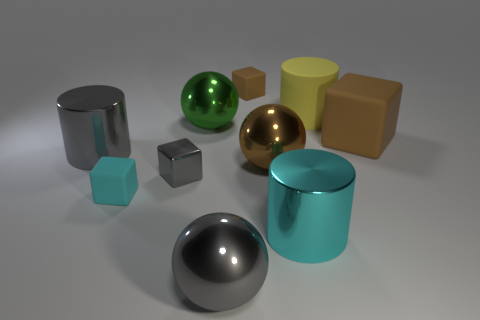Subtract all blocks. How many objects are left? 6 Add 9 big yellow matte things. How many big yellow matte things are left? 10 Add 7 yellow cylinders. How many yellow cylinders exist? 8 Subtract 0 purple spheres. How many objects are left? 10 Subtract all large brown cubes. Subtract all tiny purple balls. How many objects are left? 9 